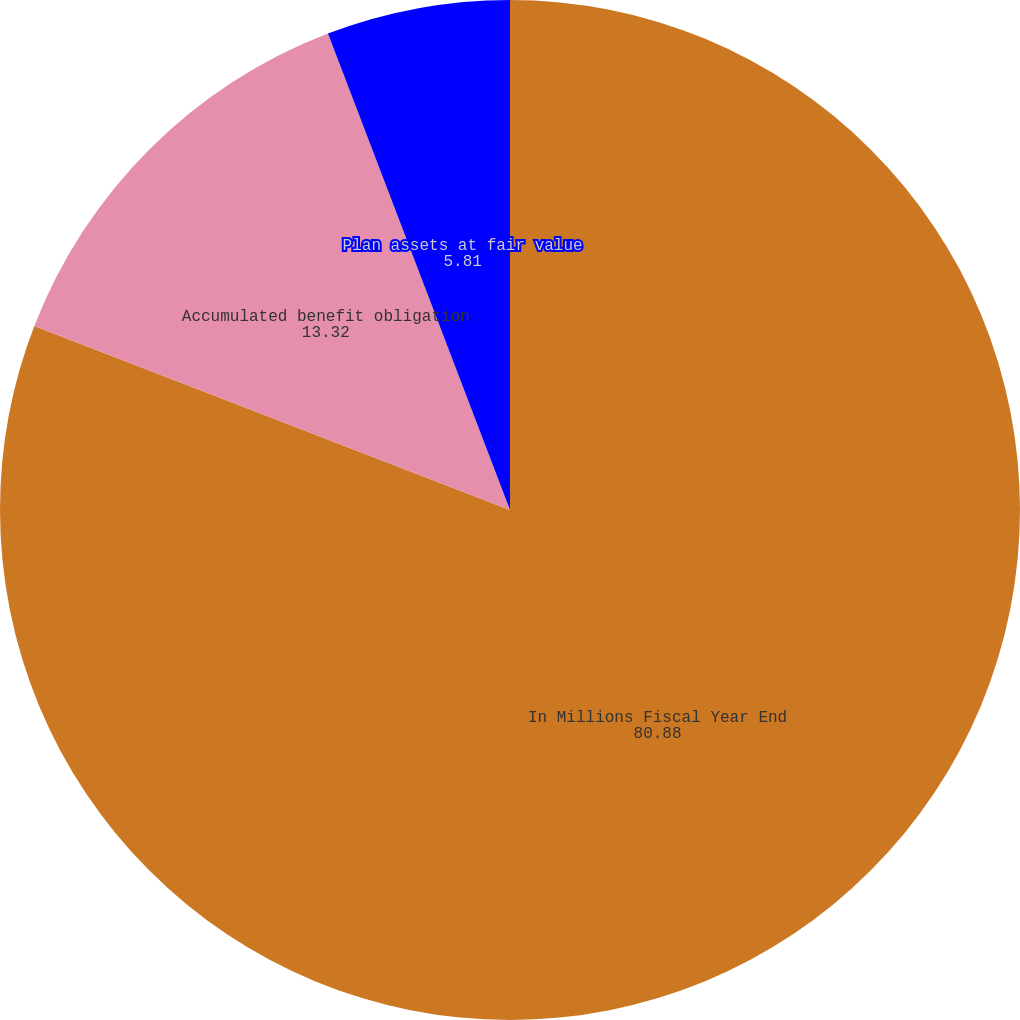Convert chart. <chart><loc_0><loc_0><loc_500><loc_500><pie_chart><fcel>In Millions Fiscal Year End<fcel>Accumulated benefit obligation<fcel>Plan assets at fair value<nl><fcel>80.88%<fcel>13.32%<fcel>5.81%<nl></chart> 